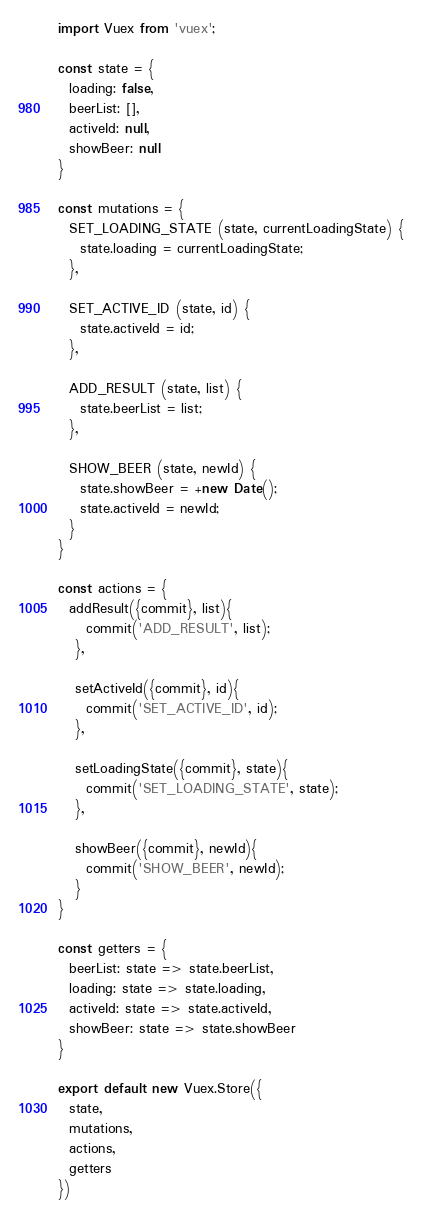Convert code to text. <code><loc_0><loc_0><loc_500><loc_500><_JavaScript_>import Vuex from 'vuex';

const state = {
  loading: false,
  beerList: [],
  activeId: null,
  showBeer: null
}

const mutations = {
  SET_LOADING_STATE (state, currentLoadingState) {
    state.loading = currentLoadingState;
  },

  SET_ACTIVE_ID (state, id) {
    state.activeId = id;
  },

  ADD_RESULT (state, list) {
    state.beerList = list;
  },

  SHOW_BEER (state, newId) {
    state.showBeer = +new Date();
    state.activeId = newId;
  }
}

const actions = {
  addResult({commit}, list){
     commit('ADD_RESULT', list);
   },

   setActiveId({commit}, id){
     commit('SET_ACTIVE_ID', id);
   },

   setLoadingState({commit}, state){
     commit('SET_LOADING_STATE', state);
   },

   showBeer({commit}, newId){
     commit('SHOW_BEER', newId);
   }
}

const getters = {
  beerList: state => state.beerList,
  loading: state => state.loading,
  activeId: state => state.activeId,
  showBeer: state => state.showBeer
}

export default new Vuex.Store({
  state,
  mutations,
  actions,
  getters
})</code> 